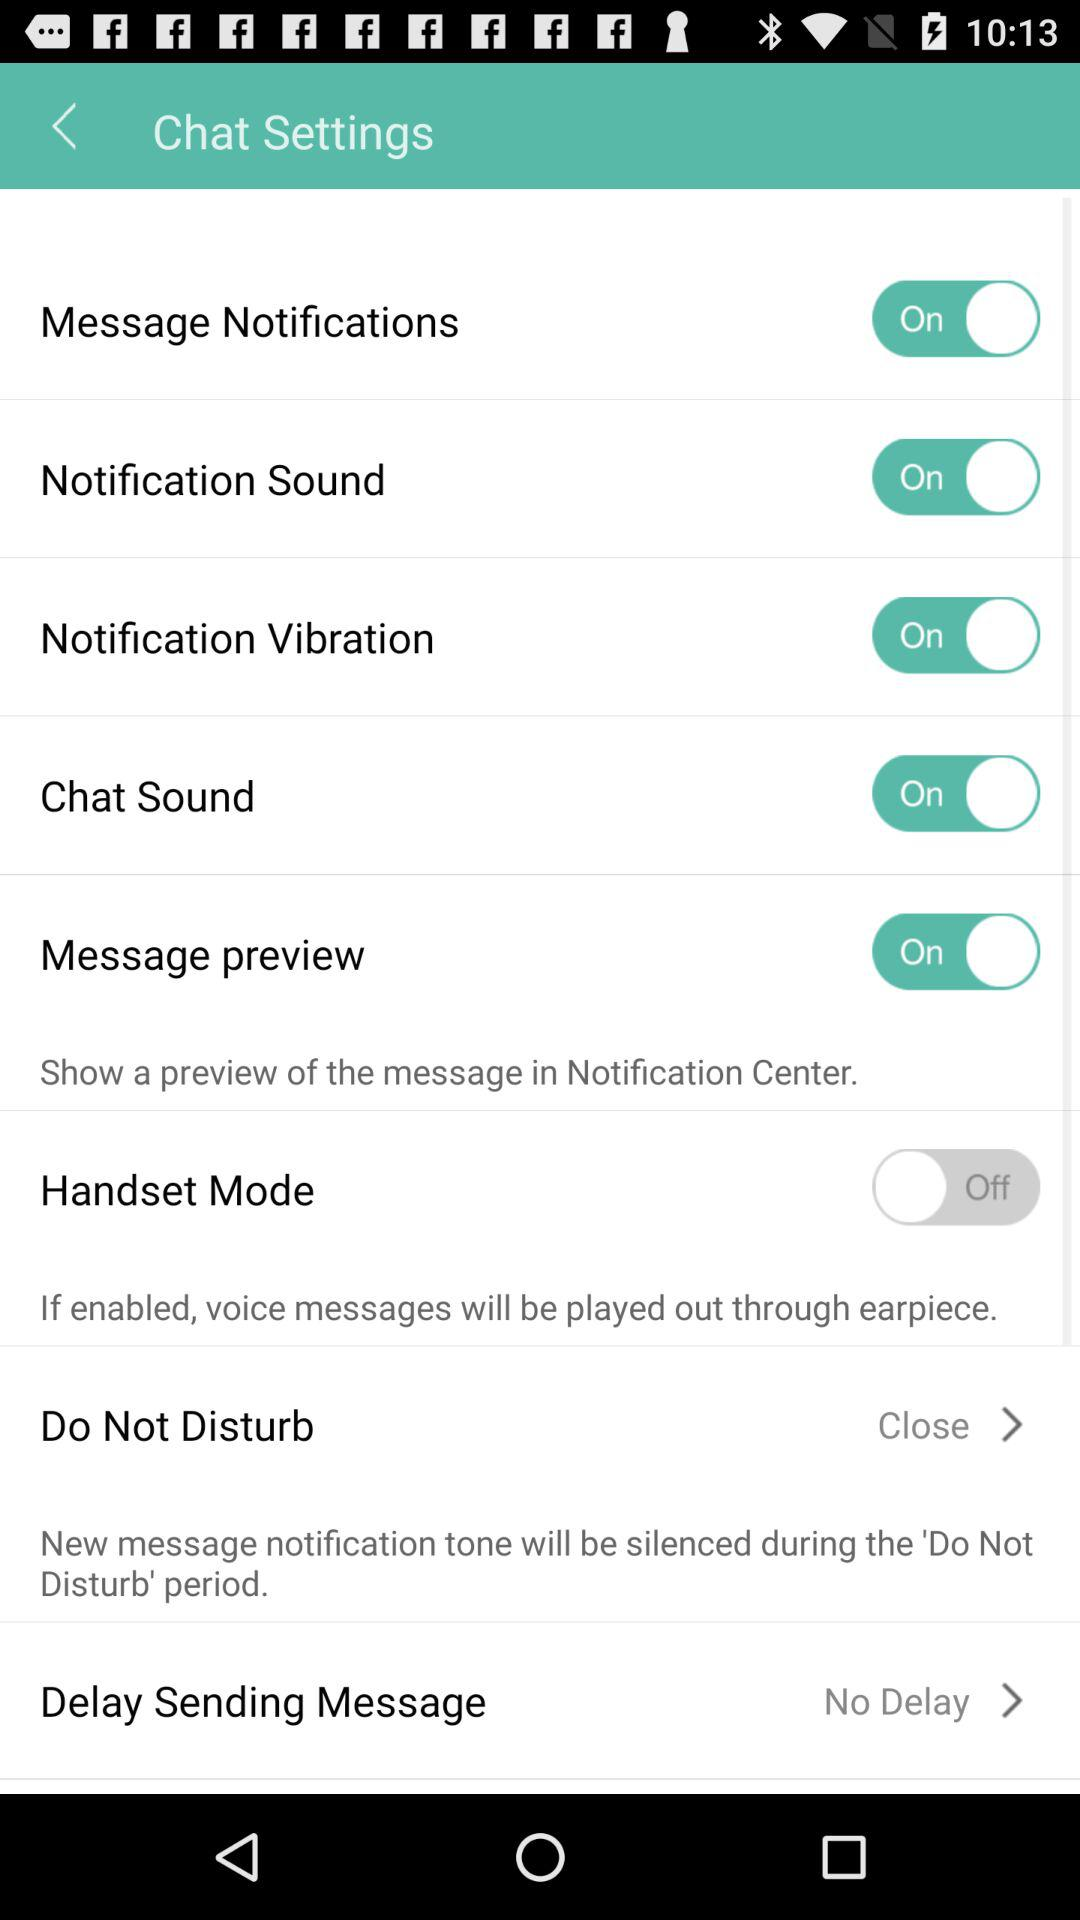What is the status of the "Message Notifications"? The status of the "Message Notifications" is "on". 